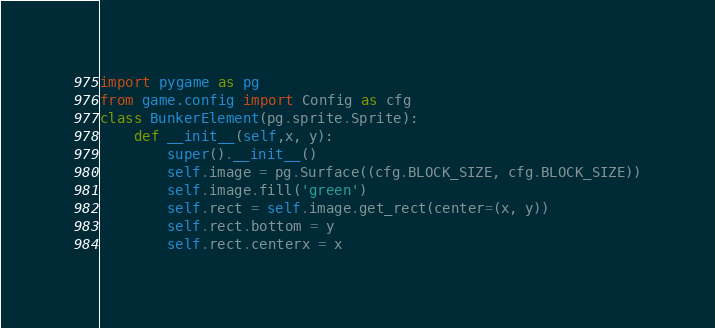Convert code to text. <code><loc_0><loc_0><loc_500><loc_500><_Python_>import pygame as pg
from game.config import Config as cfg
class BunkerElement(pg.sprite.Sprite):
    def __init__(self,x, y):
        super().__init__()
        self.image = pg.Surface((cfg.BLOCK_SIZE, cfg.BLOCK_SIZE))
        self.image.fill('green')
        self.rect = self.image.get_rect(center=(x, y))
        self.rect.bottom = y
        self.rect.centerx = x
</code> 